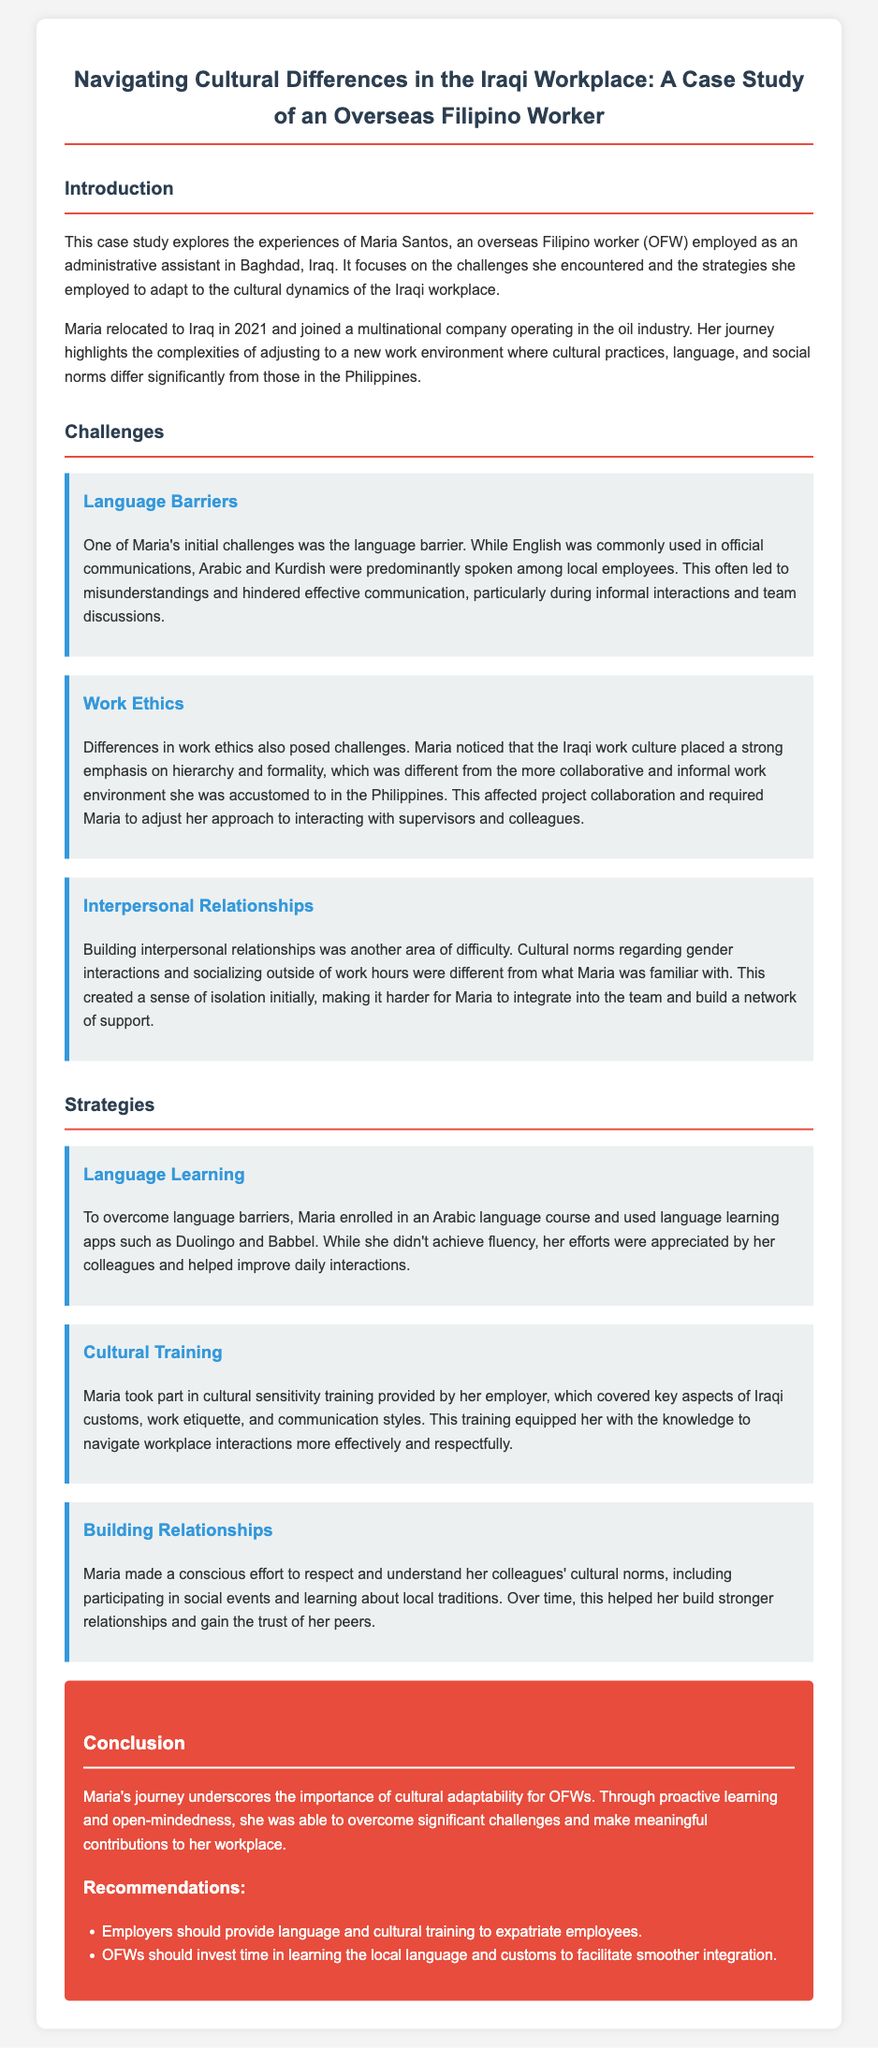What is the name of the overseas Filipino worker in the case study? The document provides the name of the overseas Filipino worker as Maria Santos.
Answer: Maria Santos In which year did Maria relocate to Iraq? The case study mentions that Maria relocated to Iraq in 2021.
Answer: 2021 What position does Maria hold in Baghdad? The document states that Maria is employed as an administrative assistant.
Answer: Administrative assistant What three challenges did Maria encounter? The document lists the challenges as language barriers, work ethics, and interpersonal relationships.
Answer: Language barriers, work ethics, interpersonal relationships What strategy did Maria use to overcome language barriers? The document notes that Maria enrolled in an Arabic language course and used language learning apps.
Answer: Enrolled in an Arabic language course What type of training did Maria participate in to adapt to workplace culture? The case study describes that Maria took part in cultural sensitivity training provided by her employer.
Answer: Cultural sensitivity training How did Maria's initial experience affect her relationships with coworkers? The document indicates that she experienced a sense of isolation initially, making it harder to build a network of support.
Answer: Sense of isolation What is one recommendation for employers mentioned in the conclusion? The document recommends that employers should provide language and cultural training to expatriate employees.
Answer: Provide language and cultural training How did Maria build stronger relationships with her colleagues? According to the document, Maria made an effort to respect and understand her colleagues' cultural norms and participated in social events.
Answer: Respected and understood cultural norms What industry is Maria's multinational company involved in? The case study specifies that the multinational company operates in the oil industry.
Answer: Oil industry 